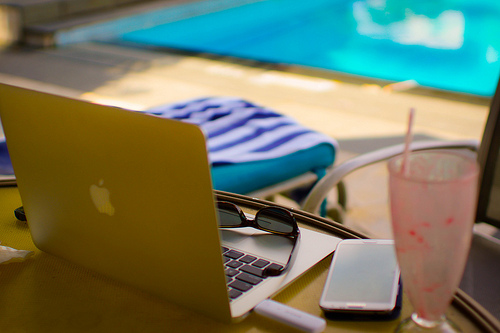<image>
Is there a glasses on the table? No. The glasses is not positioned on the table. They may be near each other, but the glasses is not supported by or resting on top of the table. Is the glass on the table? No. The glass is not positioned on the table. They may be near each other, but the glass is not supported by or resting on top of the table. 